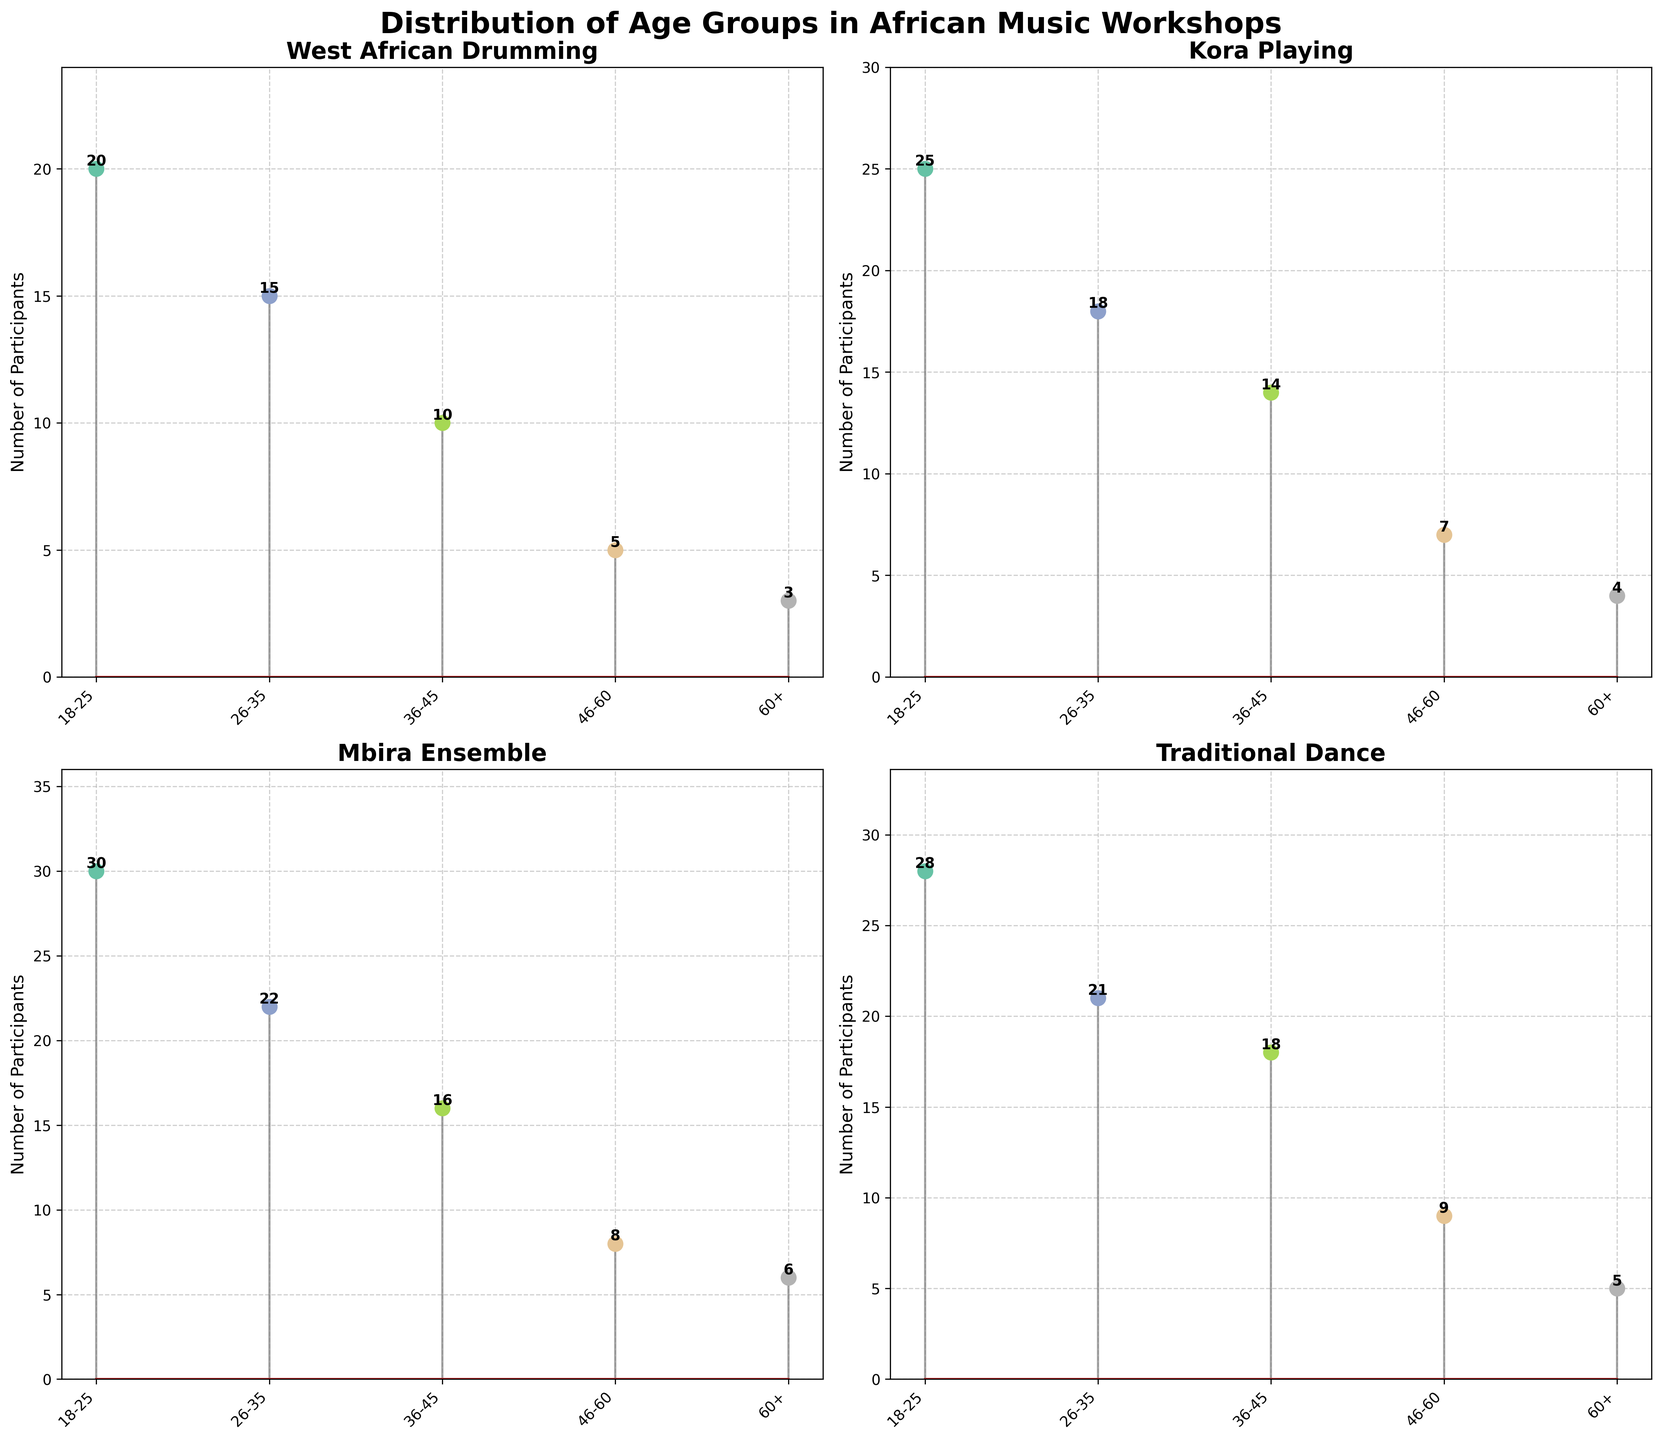What's the title of the figure? The title is displayed prominently at the top of the figure, which describes what the figure represents.
Answer: Distribution of Age Groups in African Music Workshops How many age groups are represented in each workshop? By looking at the x-axis of any subplot, we can count the distinct labels representing the age groups. Here, there are five labeled age groups: '18-25', '26-35', '36-45', '46-60', '60+'.
Answer: 5 In which age group does the Kora Playing workshop have the highest number of participants? By examining the heights of the lines in the Kora Playing subplot, we can see that the highest line corresponds to the '18-25' age group.
Answer: 18-25 What is the sum of participants in the 60+ age group across all workshops? Sum the visible number of participants in the '60+' age group from all four subplots: 3 (West African Drumming) + 4 (Kora Playing) + 6 (Mbira Ensemble) + 5 (Traditional Dance) = 18.
Answer: 18 Which workshop has the most participants in the '26-35' age group? By comparing the heights of the lines corresponding to the '26-35' age group in each subplot, the tallest line is in the Mbira Ensemble subplot with 22 participants.
Answer: Mbira Ensemble Which workshop has the smallest difference in the number of participants between the '36-45' and '46-60' age groups? The differences are: West African Drumming (10 - 5 = 5), Kora Playing (14 - 7 = 7), Mbira Ensemble (16 - 8 = 8), Traditional Dance (18 - 9 = 9). The smallest difference is for West African Drumming with a difference of 5.
Answer: West African Drumming What is the combined number of participants in the '18-25' and '26-35' age groups for Traditional Dance? Add the number of participants in the '18-25' and '26-35' age groups in the Traditional Dance subplot: 28 + 21 = 49.
Answer: 49 In the Mbira Ensemble workshop, are there more participants in the '46-60' or the '60+' age group? By comparing the heights of the lines in the Mbira Ensemble subplot, the '46-60' age group has 8 participants while the '60+' age group has 6 participants, so '46-60' has more.
Answer: 46-60 How many participants are there in the '36-45' age group in the West African Drumming workshop? By looking at the number at the end of the line in the '36-45' age group in the West African Drumming subplot, the number is 10.
Answer: 10 